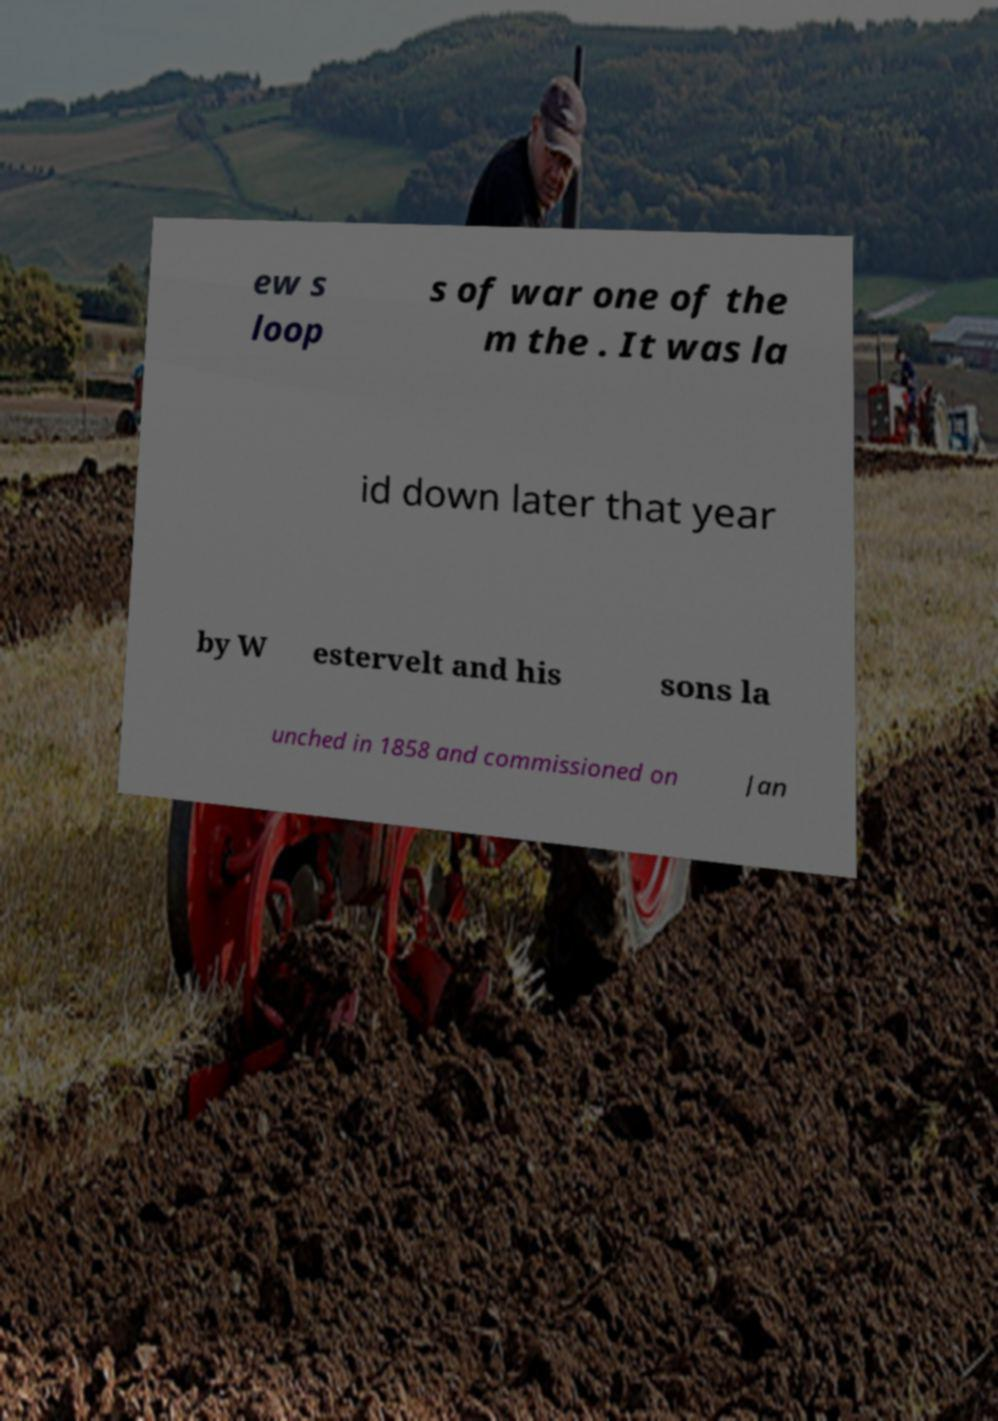Can you accurately transcribe the text from the provided image for me? ew s loop s of war one of the m the . It was la id down later that year by W estervelt and his sons la unched in 1858 and commissioned on Jan 